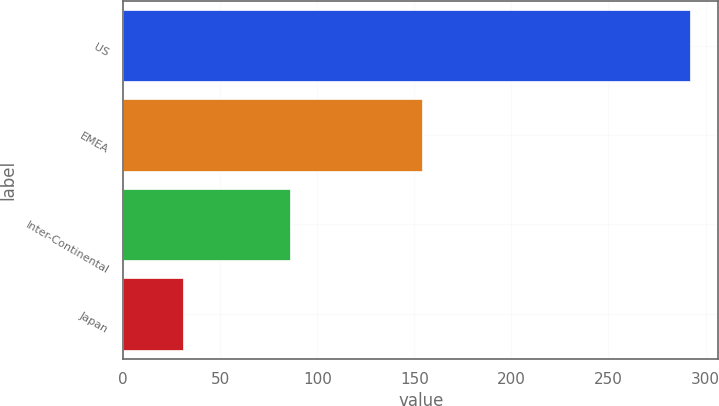Convert chart to OTSL. <chart><loc_0><loc_0><loc_500><loc_500><bar_chart><fcel>US<fcel>EMEA<fcel>Inter-Continental<fcel>Japan<nl><fcel>292<fcel>154<fcel>86<fcel>31<nl></chart> 